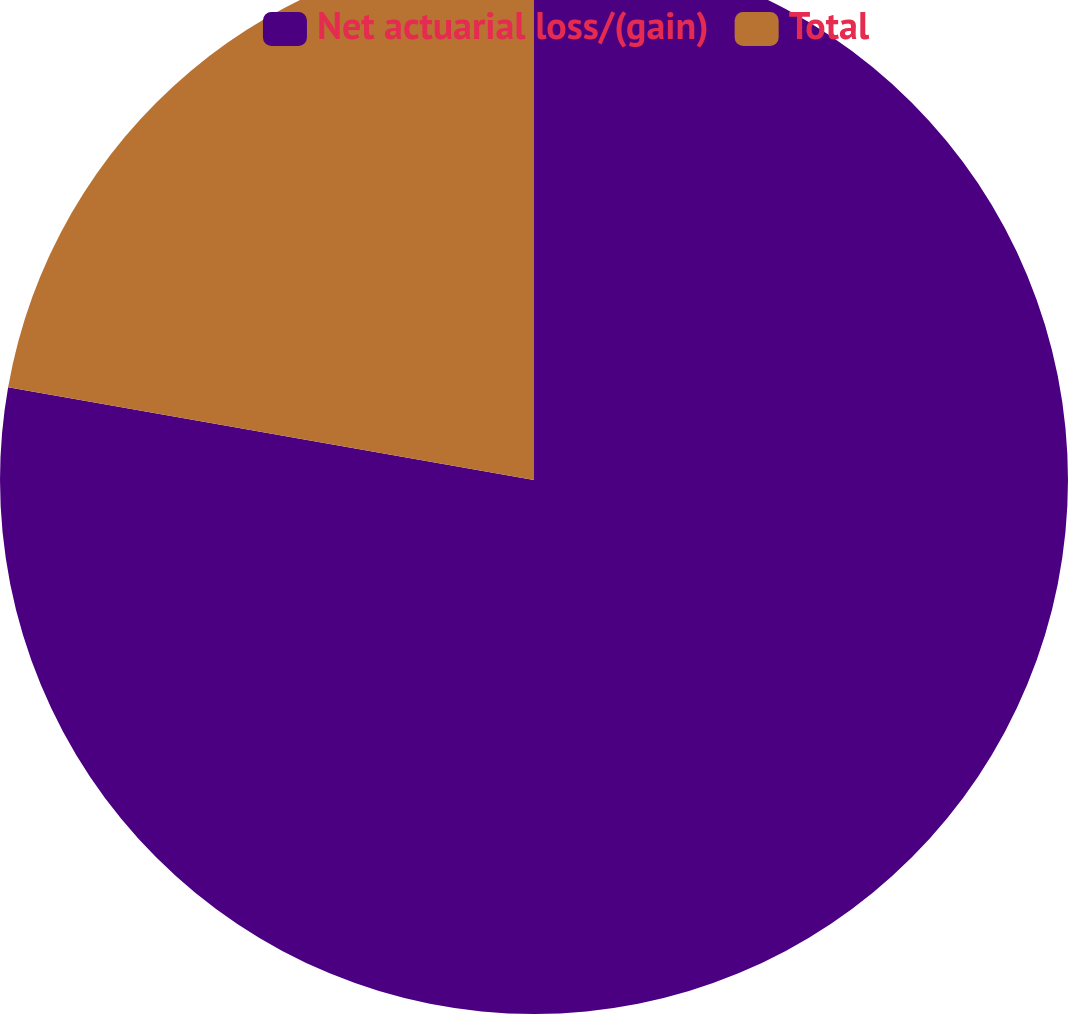Convert chart to OTSL. <chart><loc_0><loc_0><loc_500><loc_500><pie_chart><fcel>Net actuarial loss/(gain)<fcel>Total<nl><fcel>77.78%<fcel>22.22%<nl></chart> 